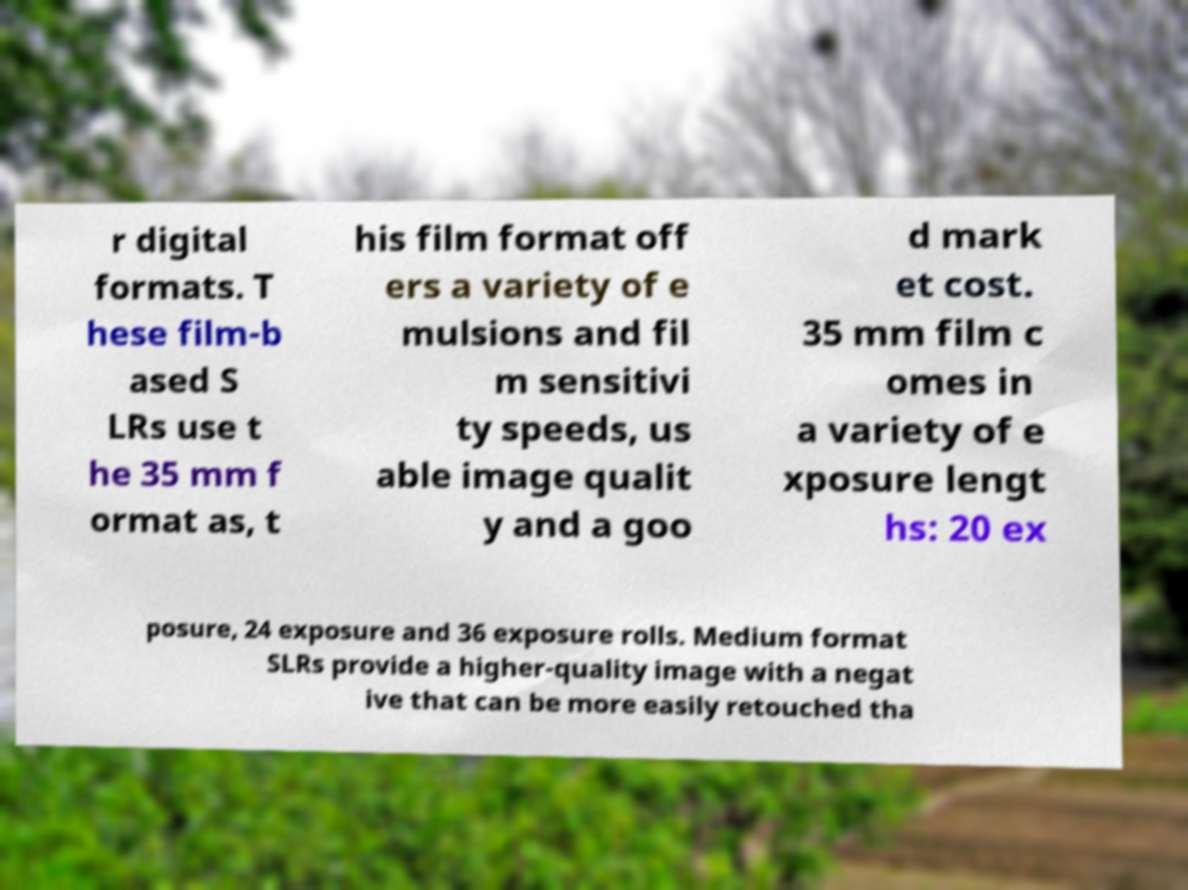Please identify and transcribe the text found in this image. r digital formats. T hese film-b ased S LRs use t he 35 mm f ormat as, t his film format off ers a variety of e mulsions and fil m sensitivi ty speeds, us able image qualit y and a goo d mark et cost. 35 mm film c omes in a variety of e xposure lengt hs: 20 ex posure, 24 exposure and 36 exposure rolls. Medium format SLRs provide a higher-quality image with a negat ive that can be more easily retouched tha 